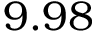<formula> <loc_0><loc_0><loc_500><loc_500>9 . 9 8</formula> 